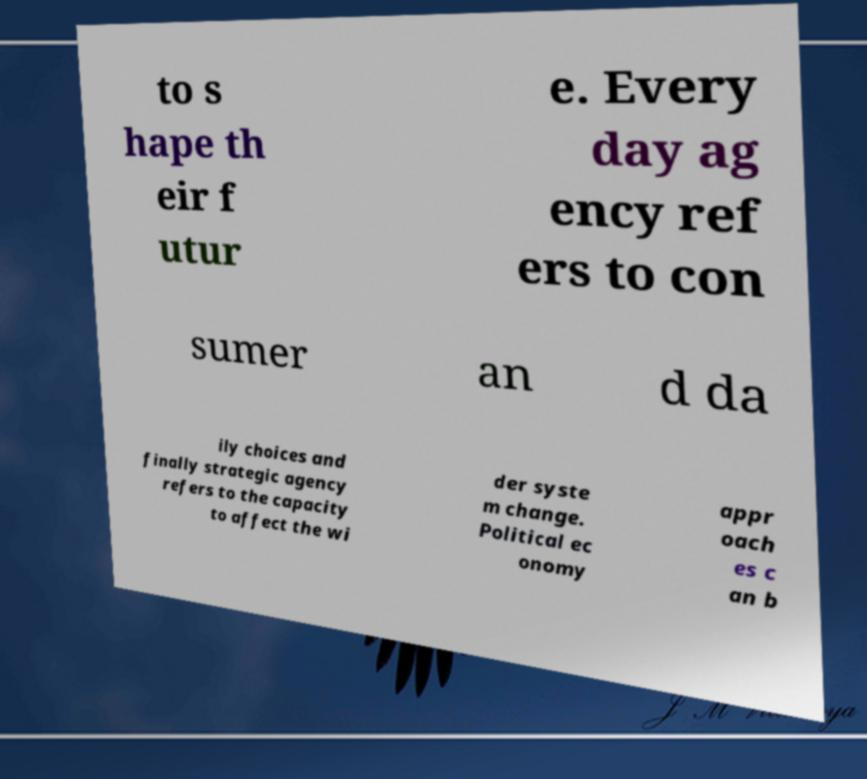Please read and relay the text visible in this image. What does it say? to s hape th eir f utur e. Every day ag ency ref ers to con sumer an d da ily choices and finally strategic agency refers to the capacity to affect the wi der syste m change. Political ec onomy appr oach es c an b 